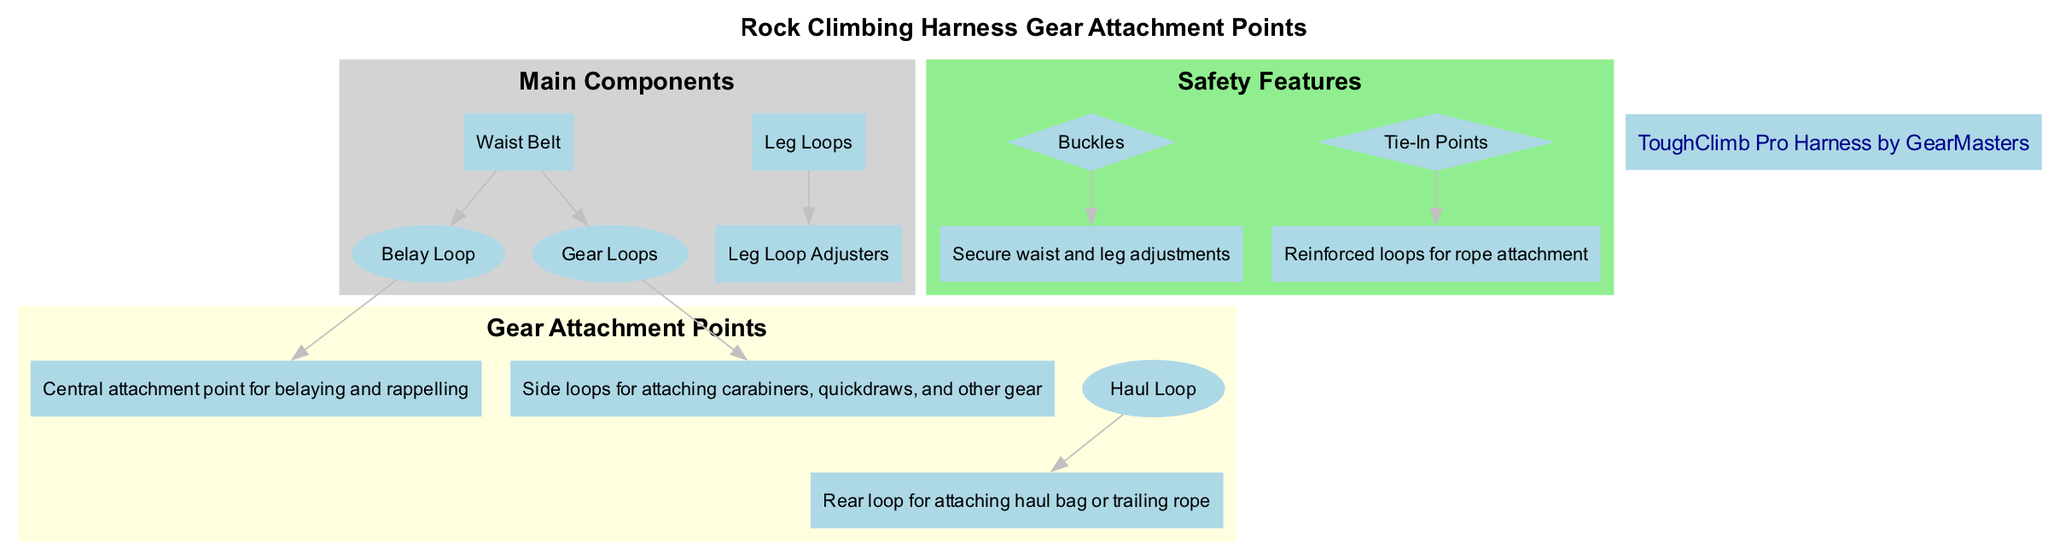what is the central attachment point for belaying? According to the diagram, the central attachment point for belaying is labeled as "Belay Loop." This attachment is highlighted under the gear attachment points section, indicating its primary function.
Answer: Belay Loop how many main components are in the harness diagram? The diagram contains two main components listed under the "Main Components" section: the "Waist Belt" and the "Leg Loops." Therefore, by counting these components, the total is determined.
Answer: 2 what is the function of the gear loops? The gear loops are described in the diagram as side loops for attaching carabiners, quickdraws, and other gear. This function is specifically indicated in the gear attachment points section under their description.
Answer: Attaching carabiners what features secure waist and leg adjustments? The safety features section of the diagram explicitly mentions "Buckles" as the components that secure waist and leg adjustments. This indicates their importance in maintaining the fit of the harness during usage.
Answer: Buckles what are the attachment points located on the waist belt? The waist belt has two attachment points listed in the diagram: the "Belay Loop" and "Gear Loops." These points are visually linked to the waist belt component in the diagram, confirming their location.
Answer: Belay Loop, Gear Loops which loop is used for attaching a haul bag? The diagram describes the "Haul Loop" as the rear loop for attaching a haul bag or a trailing rope. This specific function is mentioned, indicating its importance in climbing operations.
Answer: Haul Loop how are leg loop adjustments made? The diagram lists "Leg Loop Adjusters" as part of the leg loops, indicating that they are the components specifically responsible for adjusting the size of the leg loops on the harness.
Answer: Leg Loop Adjusters what brand is highlighted in the diagram? The brand feature in the diagram clearly highlights the "ToughClimb Pro Harness by GearMasters." This information is displayed prominently to emphasize the brand's identity within the context of the harness.
Answer: ToughClimb Pro Harness by GearMasters 